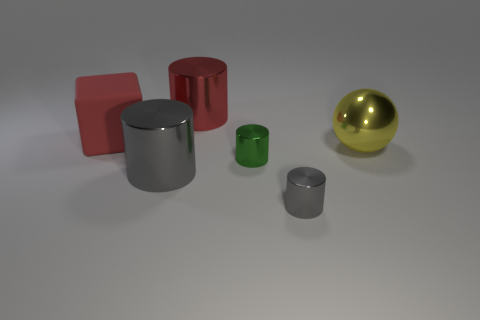Can you describe the texture and material of the objects in the foreground? Sure! The objects in the foreground include a cylinder and a sphere, both of which have a smooth texture. The cylinder appears to be made of a reflective metal, suggesting it might be aluminum or steel, while the sphere has a glossy finish and seems to be made of a material like polished brass or gold-tone metal. 